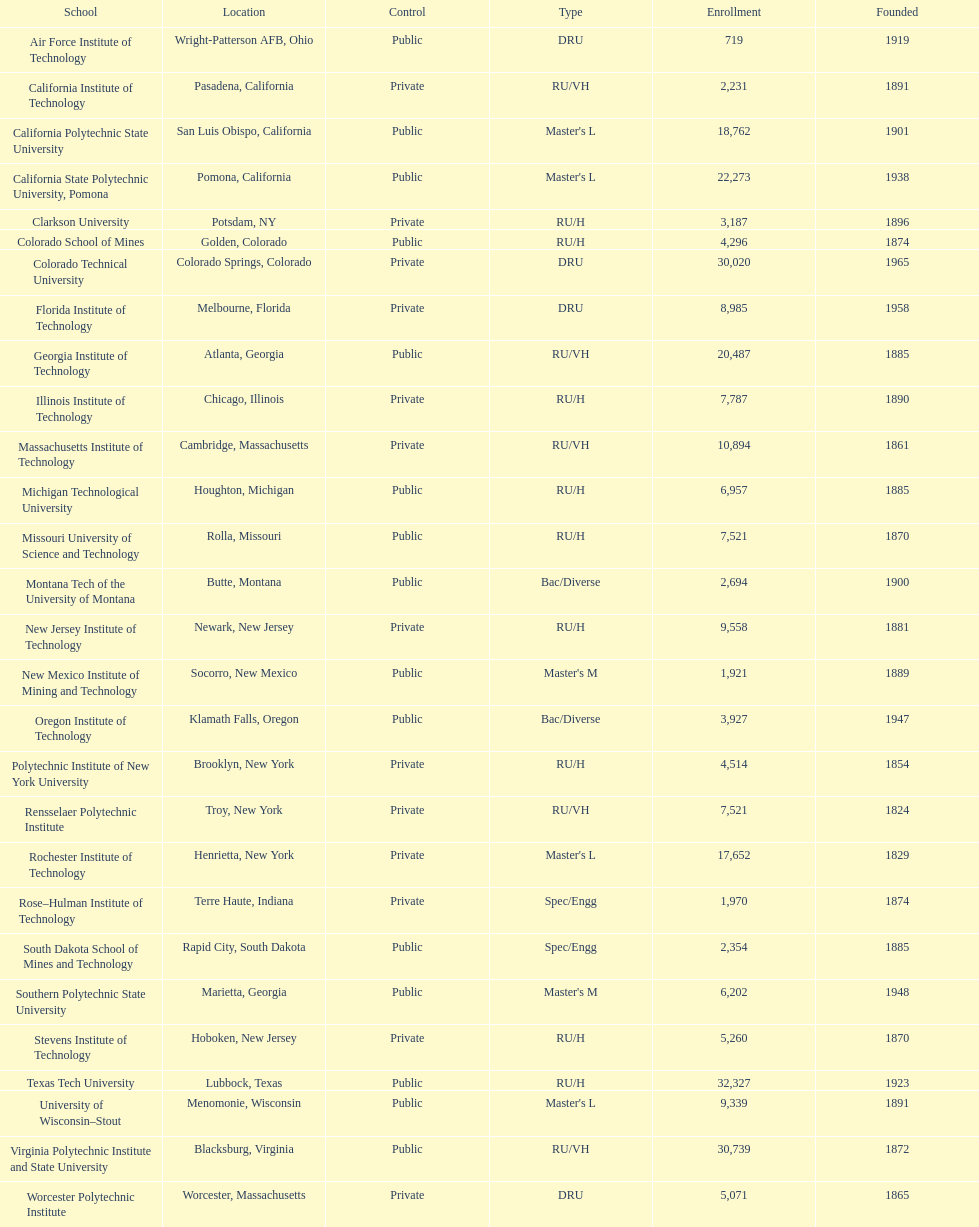What is the disparity in enrolment between the two leading schools displayed in the table? 1512. 